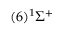<formula> <loc_0><loc_0><loc_500><loc_500>( 6 ) ^ { 1 } \Sigma ^ { + }</formula> 